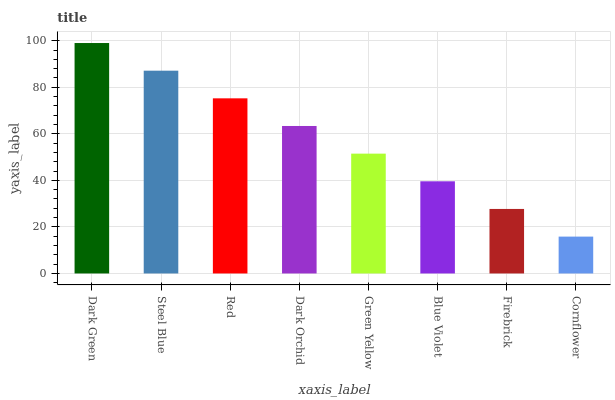Is Steel Blue the minimum?
Answer yes or no. No. Is Steel Blue the maximum?
Answer yes or no. No. Is Dark Green greater than Steel Blue?
Answer yes or no. Yes. Is Steel Blue less than Dark Green?
Answer yes or no. Yes. Is Steel Blue greater than Dark Green?
Answer yes or no. No. Is Dark Green less than Steel Blue?
Answer yes or no. No. Is Dark Orchid the high median?
Answer yes or no. Yes. Is Green Yellow the low median?
Answer yes or no. Yes. Is Firebrick the high median?
Answer yes or no. No. Is Red the low median?
Answer yes or no. No. 